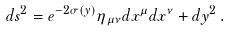<formula> <loc_0><loc_0><loc_500><loc_500>d s ^ { 2 } = { e } ^ { - 2 \sigma ( y ) } \eta _ { \mu \nu } d x ^ { \mu } d x ^ { \nu } + d y ^ { 2 } \, .</formula> 